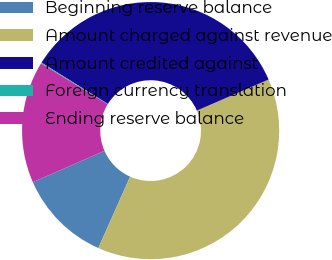Convert chart to OTSL. <chart><loc_0><loc_0><loc_500><loc_500><pie_chart><fcel>Beginning reserve balance<fcel>Amount charged against revenue<fcel>Amount credited against<fcel>Foreign currency translation<fcel>Ending reserve balance<nl><fcel>11.77%<fcel>38.17%<fcel>34.62%<fcel>0.12%<fcel>15.32%<nl></chart> 